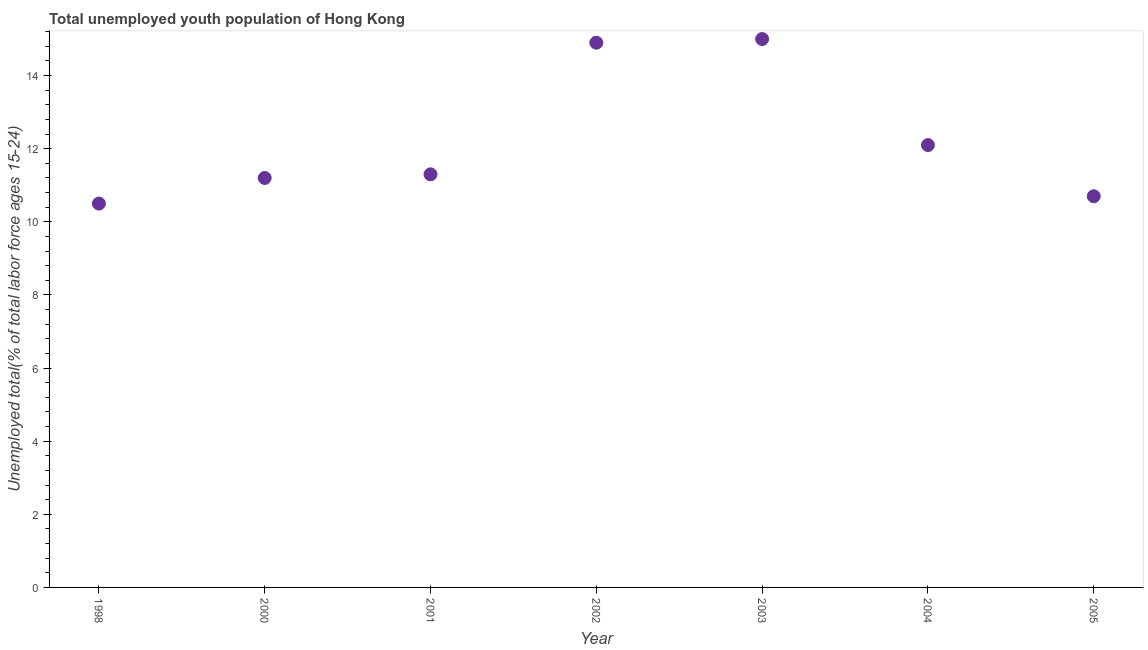What is the unemployed youth in 2002?
Give a very brief answer. 14.9. Across all years, what is the maximum unemployed youth?
Your answer should be very brief. 15. What is the sum of the unemployed youth?
Keep it short and to the point. 85.7. What is the difference between the unemployed youth in 2000 and 2002?
Offer a very short reply. -3.7. What is the average unemployed youth per year?
Provide a short and direct response. 12.24. What is the median unemployed youth?
Provide a succinct answer. 11.3. Is the unemployed youth in 2002 less than that in 2004?
Ensure brevity in your answer.  No. Is the difference between the unemployed youth in 1998 and 2004 greater than the difference between any two years?
Provide a short and direct response. No. What is the difference between the highest and the second highest unemployed youth?
Ensure brevity in your answer.  0.1. Is the sum of the unemployed youth in 2001 and 2005 greater than the maximum unemployed youth across all years?
Provide a succinct answer. Yes. What is the difference between the highest and the lowest unemployed youth?
Provide a succinct answer. 4.5. In how many years, is the unemployed youth greater than the average unemployed youth taken over all years?
Give a very brief answer. 2. How many dotlines are there?
Offer a very short reply. 1. What is the difference between two consecutive major ticks on the Y-axis?
Give a very brief answer. 2. What is the title of the graph?
Give a very brief answer. Total unemployed youth population of Hong Kong. What is the label or title of the X-axis?
Provide a short and direct response. Year. What is the label or title of the Y-axis?
Offer a very short reply. Unemployed total(% of total labor force ages 15-24). What is the Unemployed total(% of total labor force ages 15-24) in 1998?
Offer a terse response. 10.5. What is the Unemployed total(% of total labor force ages 15-24) in 2000?
Give a very brief answer. 11.2. What is the Unemployed total(% of total labor force ages 15-24) in 2001?
Keep it short and to the point. 11.3. What is the Unemployed total(% of total labor force ages 15-24) in 2002?
Keep it short and to the point. 14.9. What is the Unemployed total(% of total labor force ages 15-24) in 2004?
Give a very brief answer. 12.1. What is the Unemployed total(% of total labor force ages 15-24) in 2005?
Your answer should be very brief. 10.7. What is the difference between the Unemployed total(% of total labor force ages 15-24) in 1998 and 2000?
Make the answer very short. -0.7. What is the difference between the Unemployed total(% of total labor force ages 15-24) in 1998 and 2001?
Ensure brevity in your answer.  -0.8. What is the difference between the Unemployed total(% of total labor force ages 15-24) in 1998 and 2003?
Your response must be concise. -4.5. What is the difference between the Unemployed total(% of total labor force ages 15-24) in 1998 and 2004?
Provide a succinct answer. -1.6. What is the difference between the Unemployed total(% of total labor force ages 15-24) in 2000 and 2002?
Offer a very short reply. -3.7. What is the difference between the Unemployed total(% of total labor force ages 15-24) in 2000 and 2004?
Offer a terse response. -0.9. What is the difference between the Unemployed total(% of total labor force ages 15-24) in 2000 and 2005?
Offer a very short reply. 0.5. What is the difference between the Unemployed total(% of total labor force ages 15-24) in 2001 and 2003?
Provide a succinct answer. -3.7. What is the difference between the Unemployed total(% of total labor force ages 15-24) in 2002 and 2004?
Keep it short and to the point. 2.8. What is the difference between the Unemployed total(% of total labor force ages 15-24) in 2003 and 2004?
Offer a very short reply. 2.9. What is the ratio of the Unemployed total(% of total labor force ages 15-24) in 1998 to that in 2000?
Ensure brevity in your answer.  0.94. What is the ratio of the Unemployed total(% of total labor force ages 15-24) in 1998 to that in 2001?
Ensure brevity in your answer.  0.93. What is the ratio of the Unemployed total(% of total labor force ages 15-24) in 1998 to that in 2002?
Keep it short and to the point. 0.7. What is the ratio of the Unemployed total(% of total labor force ages 15-24) in 1998 to that in 2004?
Provide a succinct answer. 0.87. What is the ratio of the Unemployed total(% of total labor force ages 15-24) in 1998 to that in 2005?
Provide a short and direct response. 0.98. What is the ratio of the Unemployed total(% of total labor force ages 15-24) in 2000 to that in 2002?
Your answer should be very brief. 0.75. What is the ratio of the Unemployed total(% of total labor force ages 15-24) in 2000 to that in 2003?
Your response must be concise. 0.75. What is the ratio of the Unemployed total(% of total labor force ages 15-24) in 2000 to that in 2004?
Offer a terse response. 0.93. What is the ratio of the Unemployed total(% of total labor force ages 15-24) in 2000 to that in 2005?
Provide a short and direct response. 1.05. What is the ratio of the Unemployed total(% of total labor force ages 15-24) in 2001 to that in 2002?
Provide a succinct answer. 0.76. What is the ratio of the Unemployed total(% of total labor force ages 15-24) in 2001 to that in 2003?
Make the answer very short. 0.75. What is the ratio of the Unemployed total(% of total labor force ages 15-24) in 2001 to that in 2004?
Your answer should be very brief. 0.93. What is the ratio of the Unemployed total(% of total labor force ages 15-24) in 2001 to that in 2005?
Keep it short and to the point. 1.06. What is the ratio of the Unemployed total(% of total labor force ages 15-24) in 2002 to that in 2003?
Make the answer very short. 0.99. What is the ratio of the Unemployed total(% of total labor force ages 15-24) in 2002 to that in 2004?
Keep it short and to the point. 1.23. What is the ratio of the Unemployed total(% of total labor force ages 15-24) in 2002 to that in 2005?
Your answer should be compact. 1.39. What is the ratio of the Unemployed total(% of total labor force ages 15-24) in 2003 to that in 2004?
Offer a very short reply. 1.24. What is the ratio of the Unemployed total(% of total labor force ages 15-24) in 2003 to that in 2005?
Offer a terse response. 1.4. What is the ratio of the Unemployed total(% of total labor force ages 15-24) in 2004 to that in 2005?
Your answer should be compact. 1.13. 